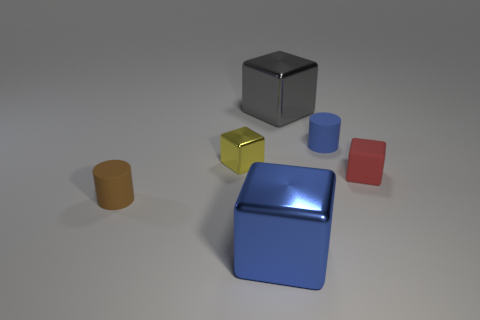Subtract 1 cubes. How many cubes are left? 3 Subtract all green cubes. Subtract all gray spheres. How many cubes are left? 4 Add 1 small matte cubes. How many objects exist? 7 Subtract all cubes. How many objects are left? 2 Subtract 0 brown spheres. How many objects are left? 6 Subtract all cyan blocks. Subtract all large gray shiny objects. How many objects are left? 5 Add 2 cylinders. How many cylinders are left? 4 Add 1 big brown rubber blocks. How many big brown rubber blocks exist? 1 